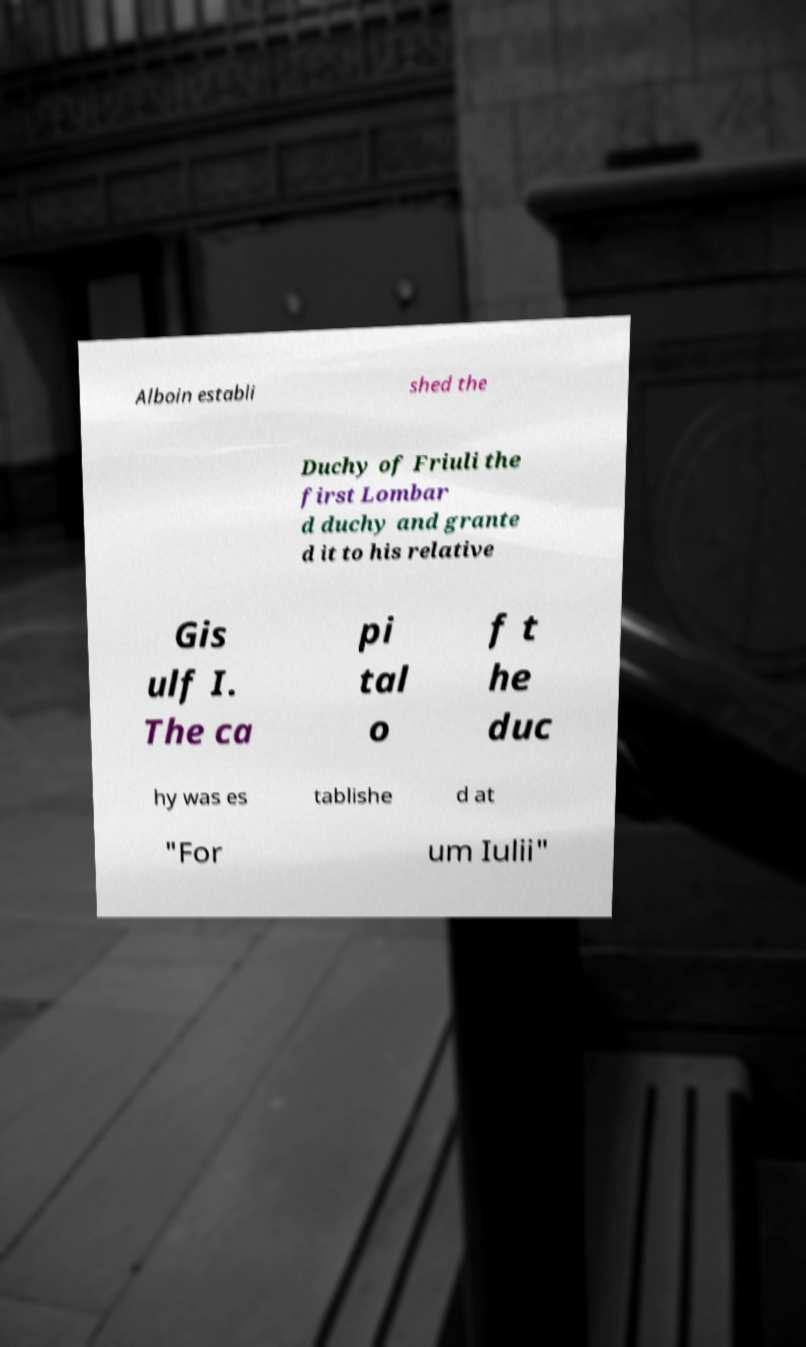Could you assist in decoding the text presented in this image and type it out clearly? Alboin establi shed the Duchy of Friuli the first Lombar d duchy and grante d it to his relative Gis ulf I. The ca pi tal o f t he duc hy was es tablishe d at "For um Iulii" 